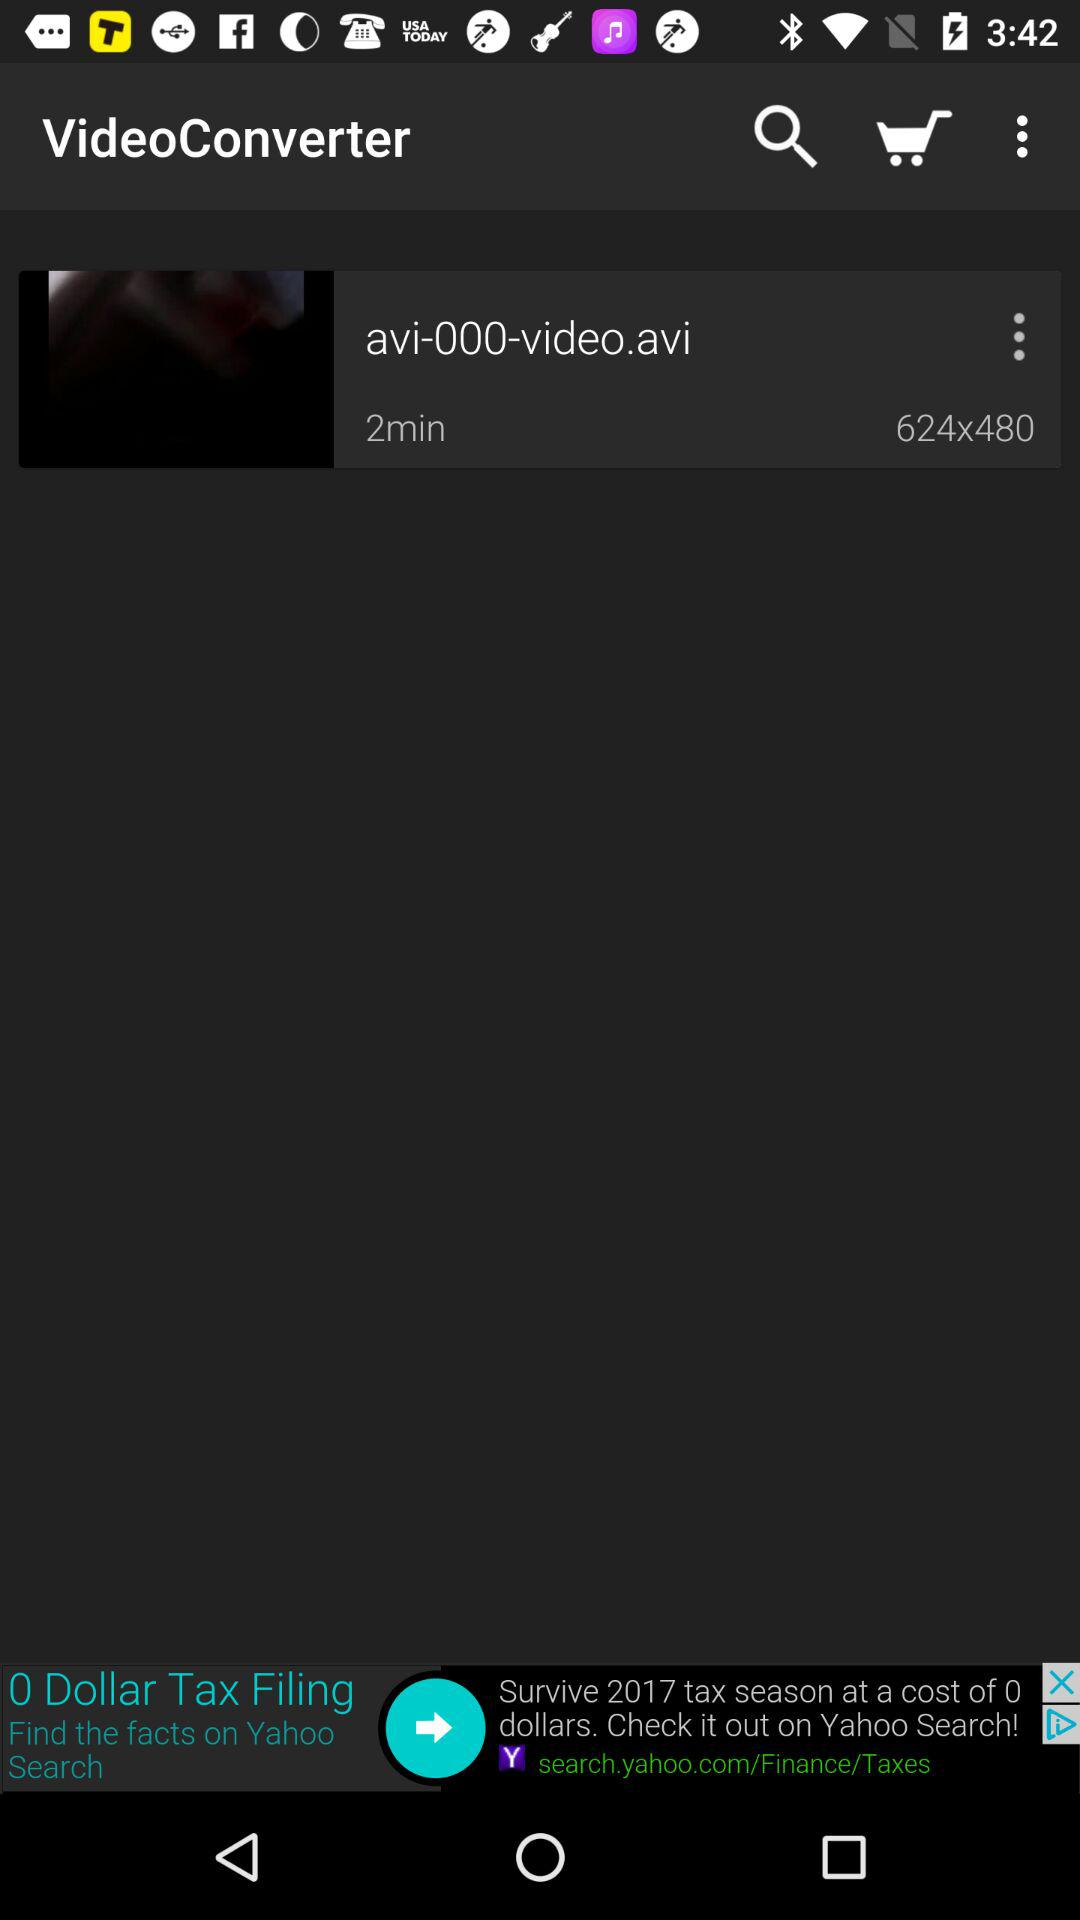What is the name of the application? The name of the application is "VideoConverter". 